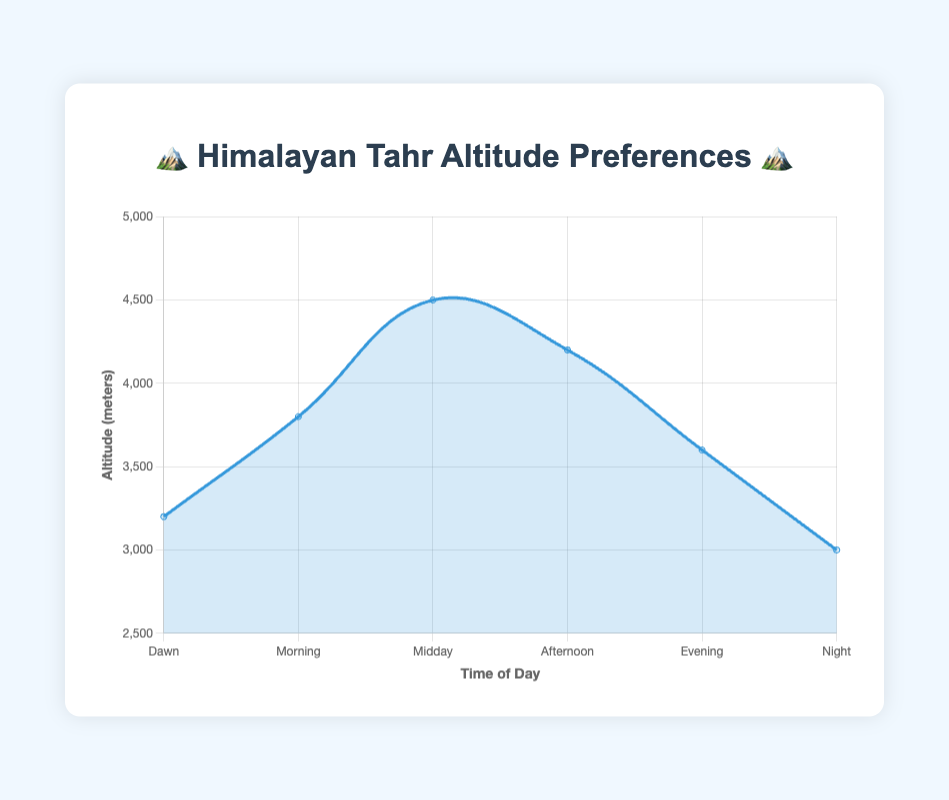What's the title of the chart? The title of the chart is displayed at the top and reads "🏔️ Himalayan Tahr Altitude Preferences 🏔️".
Answer: 🏔️ Himalayan Tahr Altitude Preferences 🏔️ At which time of day do the Himalayan Tahr prefer the highest altitude? According to the data points on the line chart, the highest average altitude is observed during "Midday".
Answer: Midday What is the average altitude preference of the Himalayan Tahr during the Evening 🏙️? From the y-axis data point corresponding to "Evening", the average altitude is 3600 meters.
Answer: 3600 meters How do the average altitudes compare between Dawn 🌅 and Night 🌙? From the chart, the average altitude at Dawn is 3200 meters and at Night it is 3000 meters. So, Dawn has a higher average altitude compared to Night.
Answer: Dawn > Night What is the difference in average altitude between the Morning 🌄 and Afternoon 🌤️? The average altitude in the Morning is 3800 meters and in the Afternoon it's 4200 meters. The difference is 4200 - 3800 = 400 meters.
Answer: 400 meters During which time of day does Himalayan Tahr exhibit the lowest altitude preference? By looking at the lowest data point on the y-axis, we see that the lowest average altitude is at Night, with 3000 meters.
Answer: Night Calculate the mean altitude preference for all times of day combined. Adding all the altitudes: 3200 + 3800 + 4500 + 4200 + 3600 + 3000 = 22300. Dividing by number of time points (6): 22300 / 6 = 3716.67 meters.
Answer: 3716.67 meters Which time of day shows a notable decrease in altitude preference just before it? Comparing consecutive data points, after Midday (4500 meters), there is a drop to Afternoon (4200 meters). This indicates a notable decrease.
Answer: Afternoon Is there a time of day where the altitude preference is exactly 3800 meters? Checking the average altitude values, the Morning has an altitude preference of exactly 3800 meters.
Answer: Morning What is the range of altitude preferences observed across different times of day? The range is found by subtracting the lowest altitude (Night, 3000 meters) from the highest altitude (Midday, 4500 meters): 4500 - 3000 = 1500 meters.
Answer: 1500 meters 